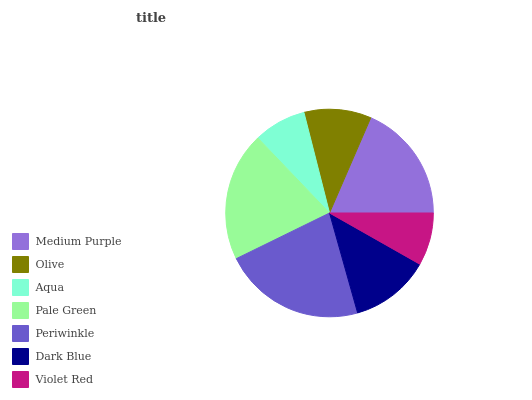Is Aqua the minimum?
Answer yes or no. Yes. Is Periwinkle the maximum?
Answer yes or no. Yes. Is Olive the minimum?
Answer yes or no. No. Is Olive the maximum?
Answer yes or no. No. Is Medium Purple greater than Olive?
Answer yes or no. Yes. Is Olive less than Medium Purple?
Answer yes or no. Yes. Is Olive greater than Medium Purple?
Answer yes or no. No. Is Medium Purple less than Olive?
Answer yes or no. No. Is Dark Blue the high median?
Answer yes or no. Yes. Is Dark Blue the low median?
Answer yes or no. Yes. Is Aqua the high median?
Answer yes or no. No. Is Olive the low median?
Answer yes or no. No. 